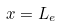Convert formula to latex. <formula><loc_0><loc_0><loc_500><loc_500>x = L _ { e }</formula> 